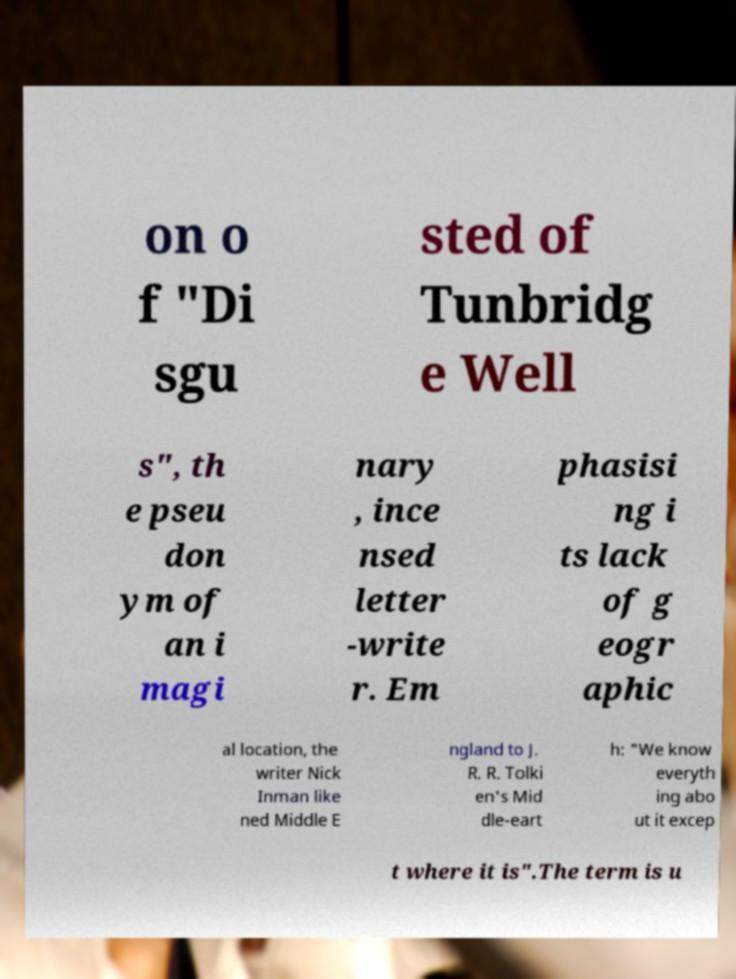For documentation purposes, I need the text within this image transcribed. Could you provide that? on o f "Di sgu sted of Tunbridg e Well s", th e pseu don ym of an i magi nary , ince nsed letter -write r. Em phasisi ng i ts lack of g eogr aphic al location, the writer Nick Inman like ned Middle E ngland to J. R. R. Tolki en's Mid dle-eart h: "We know everyth ing abo ut it excep t where it is".The term is u 